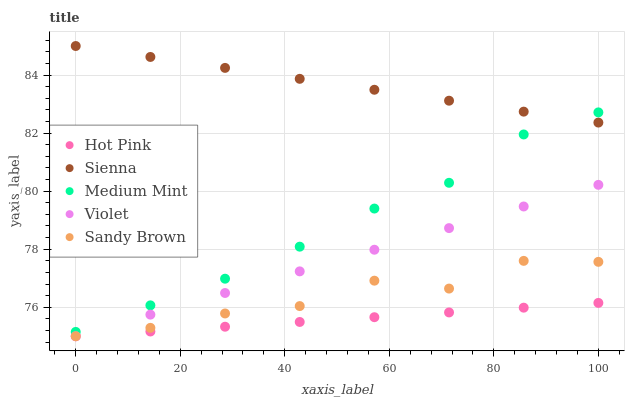Does Hot Pink have the minimum area under the curve?
Answer yes or no. Yes. Does Sienna have the maximum area under the curve?
Answer yes or no. Yes. Does Medium Mint have the minimum area under the curve?
Answer yes or no. No. Does Medium Mint have the maximum area under the curve?
Answer yes or no. No. Is Hot Pink the smoothest?
Answer yes or no. Yes. Is Sandy Brown the roughest?
Answer yes or no. Yes. Is Medium Mint the smoothest?
Answer yes or no. No. Is Medium Mint the roughest?
Answer yes or no. No. Does Hot Pink have the lowest value?
Answer yes or no. Yes. Does Medium Mint have the lowest value?
Answer yes or no. No. Does Sienna have the highest value?
Answer yes or no. Yes. Does Medium Mint have the highest value?
Answer yes or no. No. Is Violet less than Sienna?
Answer yes or no. Yes. Is Sienna greater than Violet?
Answer yes or no. Yes. Does Sandy Brown intersect Hot Pink?
Answer yes or no. Yes. Is Sandy Brown less than Hot Pink?
Answer yes or no. No. Is Sandy Brown greater than Hot Pink?
Answer yes or no. No. Does Violet intersect Sienna?
Answer yes or no. No. 